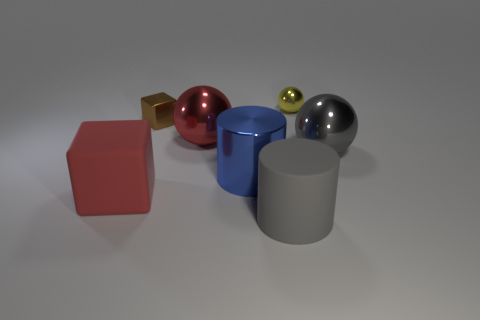Subtract 1 spheres. How many spheres are left? 2 Subtract all yellow metallic balls. How many balls are left? 2 Add 1 red balls. How many objects exist? 8 Subtract all red matte cubes. Subtract all big gray metal spheres. How many objects are left? 5 Add 3 red objects. How many red objects are left? 5 Add 7 large gray spheres. How many large gray spheres exist? 8 Subtract 1 gray cylinders. How many objects are left? 6 Subtract all blocks. How many objects are left? 5 